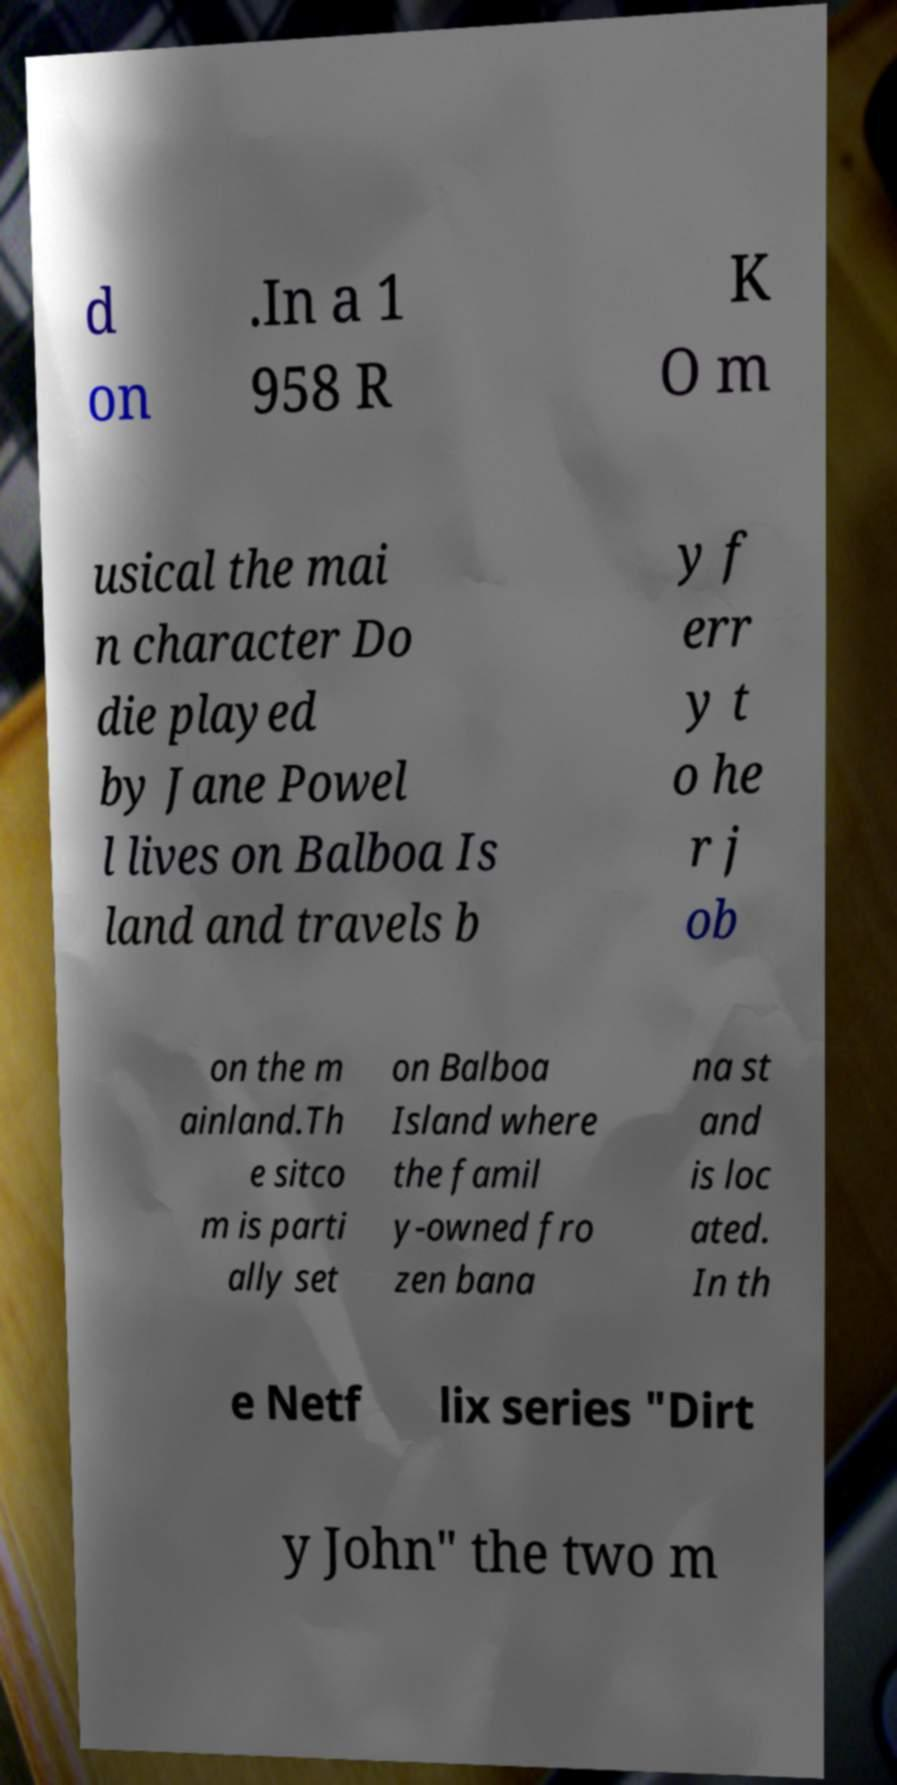I need the written content from this picture converted into text. Can you do that? d on .In a 1 958 R K O m usical the mai n character Do die played by Jane Powel l lives on Balboa Is land and travels b y f err y t o he r j ob on the m ainland.Th e sitco m is parti ally set on Balboa Island where the famil y-owned fro zen bana na st and is loc ated. In th e Netf lix series "Dirt y John" the two m 